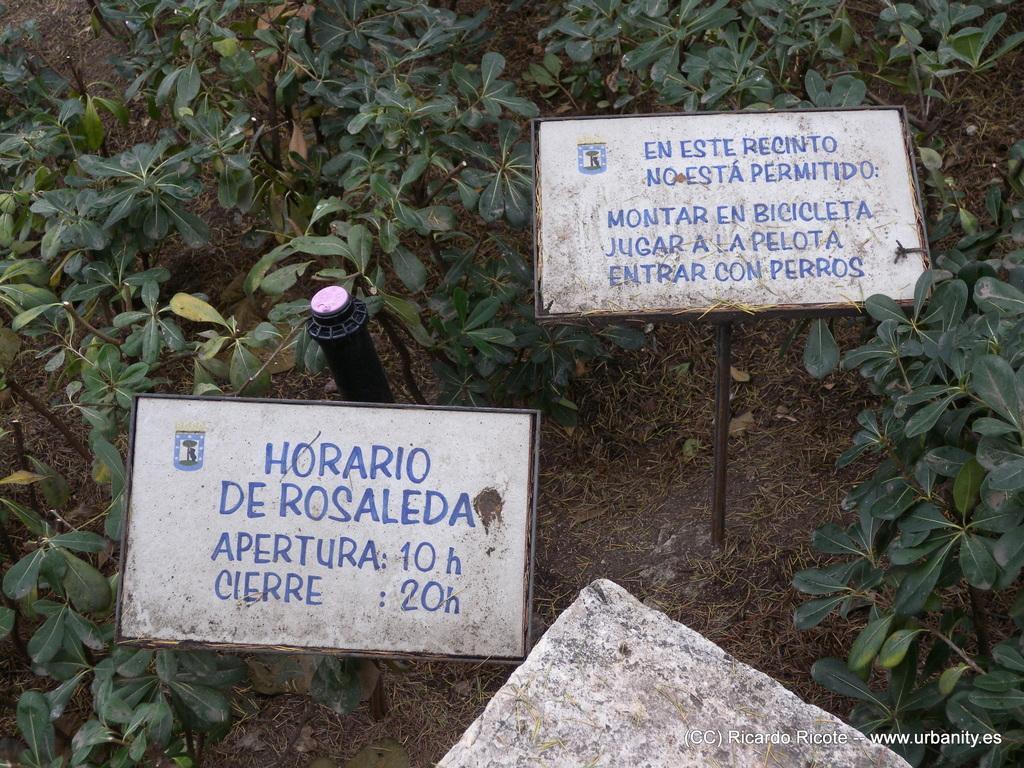Describe this image in one or two sentences. The picture consists of plants, hoardings, grass, dry leaves and soil. In the center of the picture there is a sprinkler. 